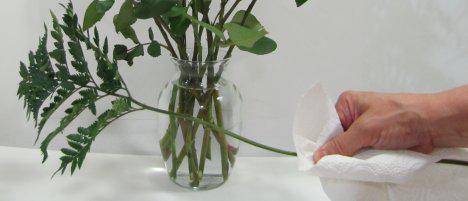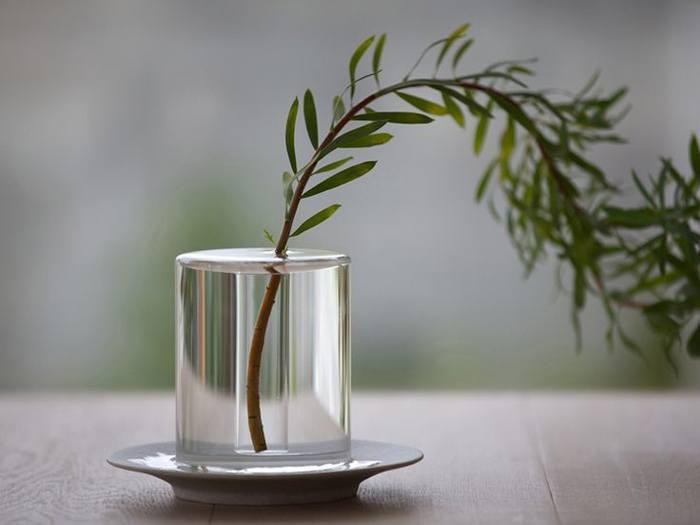The first image is the image on the left, the second image is the image on the right. Evaluate the accuracy of this statement regarding the images: "To the right, it appears as though one branch is held within a vase.". Is it true? Answer yes or no. Yes. 